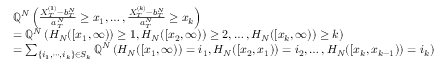<formula> <loc_0><loc_0><loc_500><loc_500>\begin{array} { r l } & { { \mathbb { Q } } ^ { N } \left ( \frac { X _ { T } ^ { ( 1 ) } - b _ { T } ^ { N } } { a _ { T } ^ { N } } \geq x _ { 1 } , \dots , \frac { X _ { T } ^ { ( k ) } - b _ { T } ^ { N } } { a _ { T } ^ { N } } \geq x _ { k } \right ) } \\ & { = { \mathbb { Q } } ^ { N } \left ( H _ { N } ( [ x _ { 1 } , \infty ) ) \geq 1 , H _ { N } ( [ x _ { 2 } , \infty ) ) \geq 2 , \dots , H _ { N } ( [ x _ { k } , \infty ) ) \geq k \right ) } \\ & { = \sum _ { \{ i _ { 1 } , \cdots , i _ { k } \} \in S _ { k } } { \mathbb { Q } } ^ { N } \left ( H _ { N } ( [ x _ { 1 } , \infty ) ) = i _ { 1 } , H _ { N } ( [ x _ { 2 } , x _ { 1 } ) ) = i _ { 2 } , \dots , H _ { N } ( [ x _ { k } , x _ { k - 1 } ) ) = i _ { k } \right ) } \end{array}</formula> 